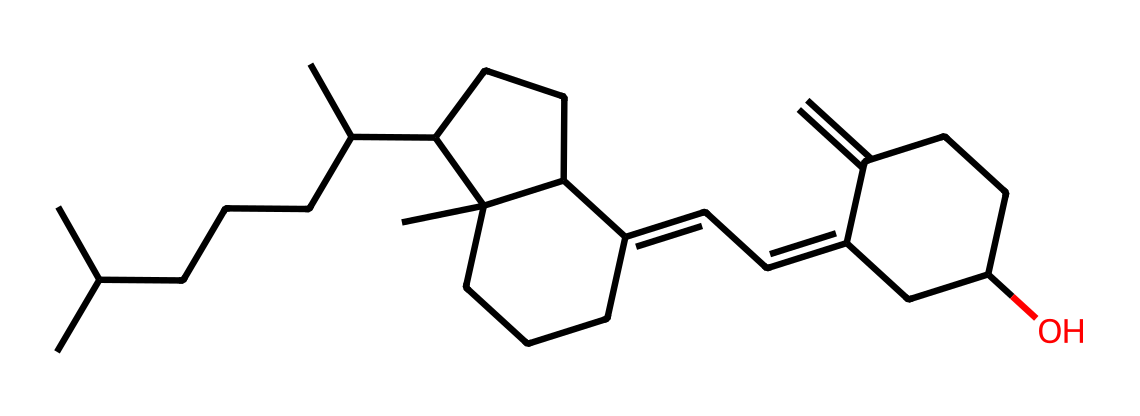What is the name of this compound? This compound is a steroid and is commonly known as vitamin D3 (cholecalciferol). It can be identified based on its unique structure, which includes a steroid backbone.
Answer: vitamin D3 How many carbon atoms are present in the structure? By analyzing the SMILES representation, we can count the number of "C" characters that represent carbon atoms. There are 27 carbon atoms in this structure.
Answer: 27 What type of functional group is present in this vitamin D molecule? The molecule contains a hydroxyl (-OH) functional group as indicated by its structure. In the SMILES, the presence of “O” followed by hydrogen bonds to carbon indicates a hydroxyl group.
Answer: hydroxyl Does this molecule have any double bonds? Yes, from the SMILES representation, several instances of "C=C" indicate the presence of double bonds between carbon atoms in the structure.
Answer: yes Is this compound hydrophilic or hydrophobic? Given its molecular structure and predominantly nonpolar nature with long hydrocarbon chains, this molecule is classified as hydrophobic.
Answer: hydrophobic Which biological process mainly leads to the synthesis of this vitamin? The primary process is photolysis or photoconversion during which UVB rays from sunlight convert 7-dehydrocholesterol in the skin into vitamin D3.
Answer: photolysis 